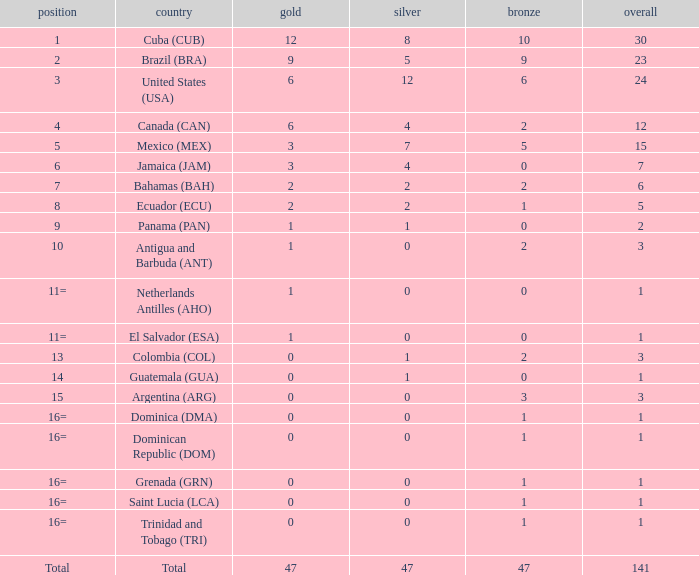What is the total gold with a total less than 1? None. Parse the table in full. {'header': ['position', 'country', 'gold', 'silver', 'bronze', 'overall'], 'rows': [['1', 'Cuba (CUB)', '12', '8', '10', '30'], ['2', 'Brazil (BRA)', '9', '5', '9', '23'], ['3', 'United States (USA)', '6', '12', '6', '24'], ['4', 'Canada (CAN)', '6', '4', '2', '12'], ['5', 'Mexico (MEX)', '3', '7', '5', '15'], ['6', 'Jamaica (JAM)', '3', '4', '0', '7'], ['7', 'Bahamas (BAH)', '2', '2', '2', '6'], ['8', 'Ecuador (ECU)', '2', '2', '1', '5'], ['9', 'Panama (PAN)', '1', '1', '0', '2'], ['10', 'Antigua and Barbuda (ANT)', '1', '0', '2', '3'], ['11=', 'Netherlands Antilles (AHO)', '1', '0', '0', '1'], ['11=', 'El Salvador (ESA)', '1', '0', '0', '1'], ['13', 'Colombia (COL)', '0', '1', '2', '3'], ['14', 'Guatemala (GUA)', '0', '1', '0', '1'], ['15', 'Argentina (ARG)', '0', '0', '3', '3'], ['16=', 'Dominica (DMA)', '0', '0', '1', '1'], ['16=', 'Dominican Republic (DOM)', '0', '0', '1', '1'], ['16=', 'Grenada (GRN)', '0', '0', '1', '1'], ['16=', 'Saint Lucia (LCA)', '0', '0', '1', '1'], ['16=', 'Trinidad and Tobago (TRI)', '0', '0', '1', '1'], ['Total', 'Total', '47', '47', '47', '141']]} 